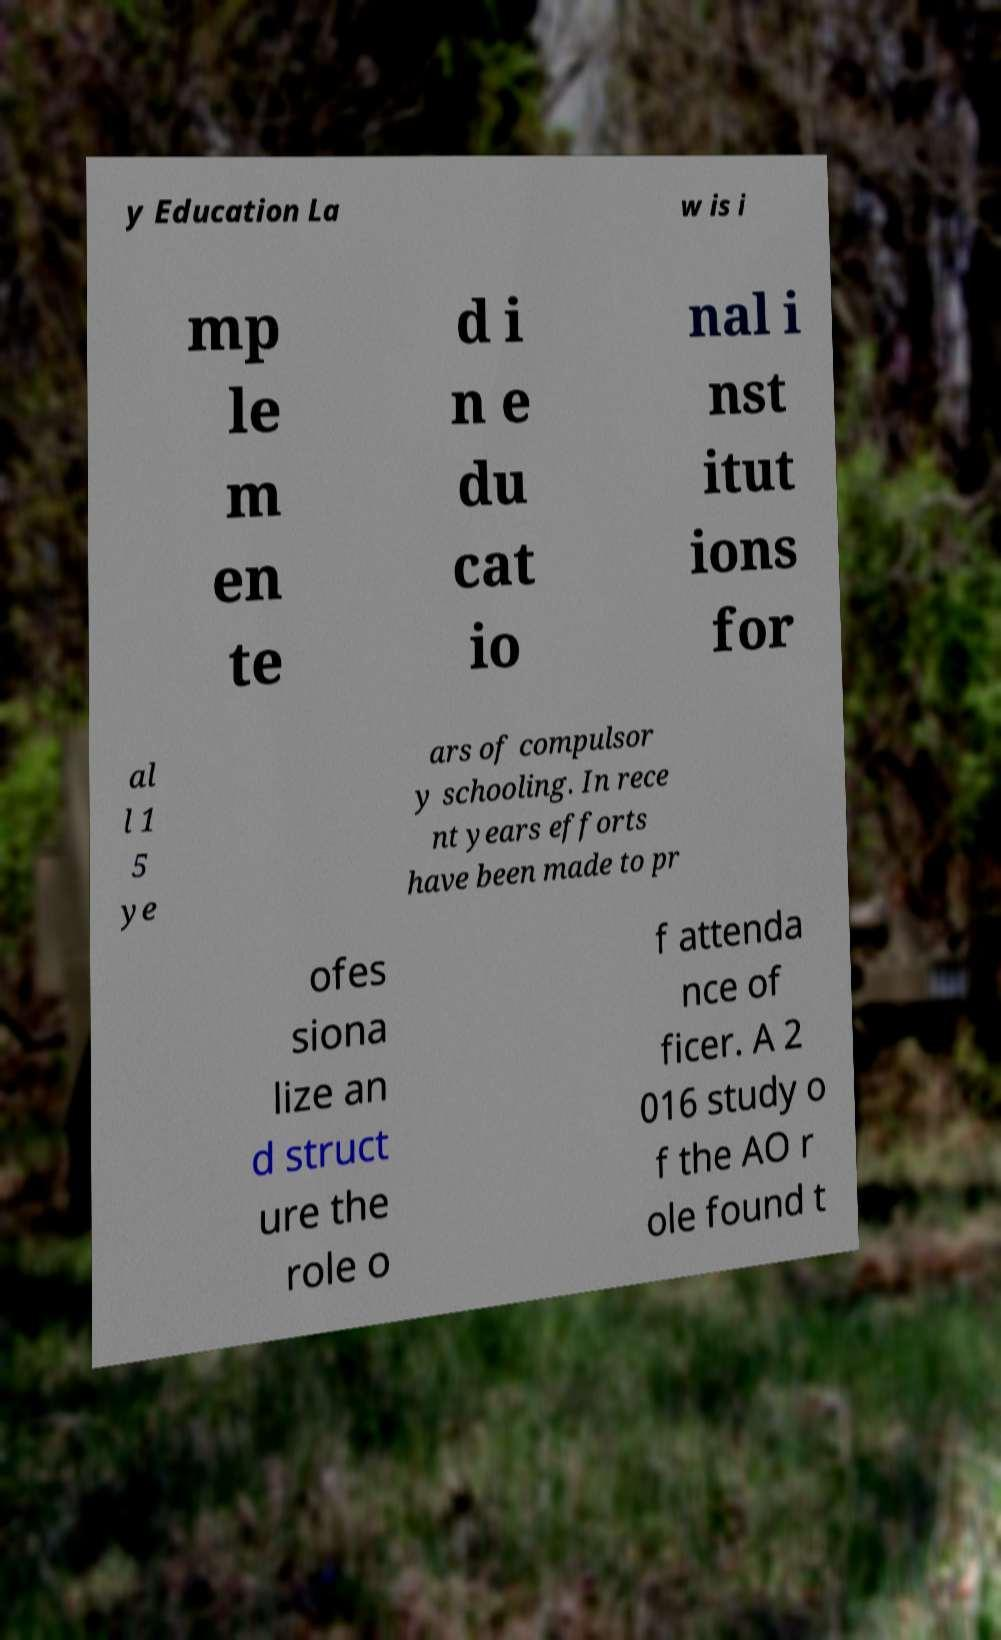Could you extract and type out the text from this image? y Education La w is i mp le m en te d i n e du cat io nal i nst itut ions for al l 1 5 ye ars of compulsor y schooling. In rece nt years efforts have been made to pr ofes siona lize an d struct ure the role o f attenda nce of ficer. A 2 016 study o f the AO r ole found t 